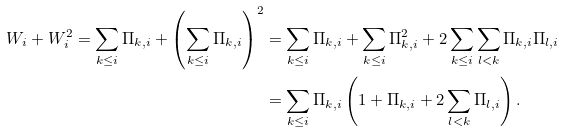<formula> <loc_0><loc_0><loc_500><loc_500>W _ { i } + W _ { i } ^ { 2 } = \sum _ { k \leq i } \Pi _ { k , i } + \left ( \sum _ { k \leq i } \Pi _ { k , i } \right ) ^ { 2 } & = \sum _ { k \leq i } \Pi _ { k , i } + \sum _ { k \leq i } \Pi _ { k , i } ^ { 2 } + 2 \sum _ { k \leq i } \sum _ { l < k } \Pi _ { k , i } \Pi _ { l , i } \\ & = \sum _ { k \leq i } \Pi _ { k , i } \left ( 1 + \Pi _ { k , i } + 2 \sum _ { l < k } \Pi _ { l , i } \right ) .</formula> 